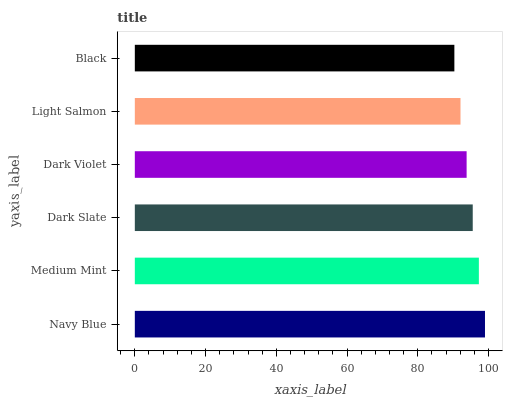Is Black the minimum?
Answer yes or no. Yes. Is Navy Blue the maximum?
Answer yes or no. Yes. Is Medium Mint the minimum?
Answer yes or no. No. Is Medium Mint the maximum?
Answer yes or no. No. Is Navy Blue greater than Medium Mint?
Answer yes or no. Yes. Is Medium Mint less than Navy Blue?
Answer yes or no. Yes. Is Medium Mint greater than Navy Blue?
Answer yes or no. No. Is Navy Blue less than Medium Mint?
Answer yes or no. No. Is Dark Slate the high median?
Answer yes or no. Yes. Is Dark Violet the low median?
Answer yes or no. Yes. Is Dark Violet the high median?
Answer yes or no. No. Is Medium Mint the low median?
Answer yes or no. No. 